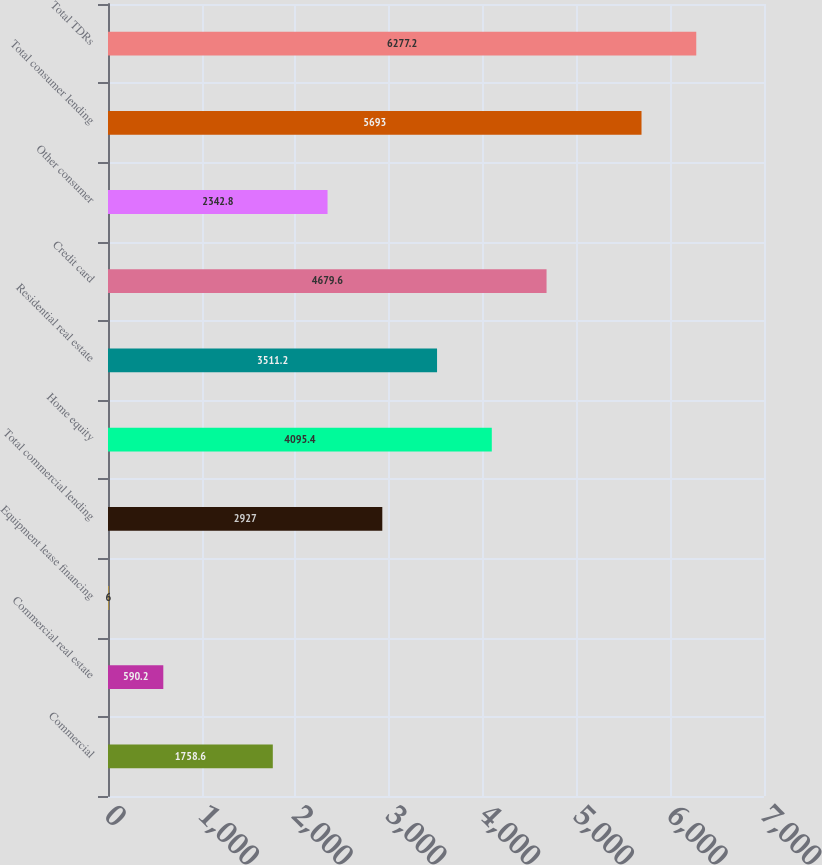<chart> <loc_0><loc_0><loc_500><loc_500><bar_chart><fcel>Commercial<fcel>Commercial real estate<fcel>Equipment lease financing<fcel>Total commercial lending<fcel>Home equity<fcel>Residential real estate<fcel>Credit card<fcel>Other consumer<fcel>Total consumer lending<fcel>Total TDRs<nl><fcel>1758.6<fcel>590.2<fcel>6<fcel>2927<fcel>4095.4<fcel>3511.2<fcel>4679.6<fcel>2342.8<fcel>5693<fcel>6277.2<nl></chart> 